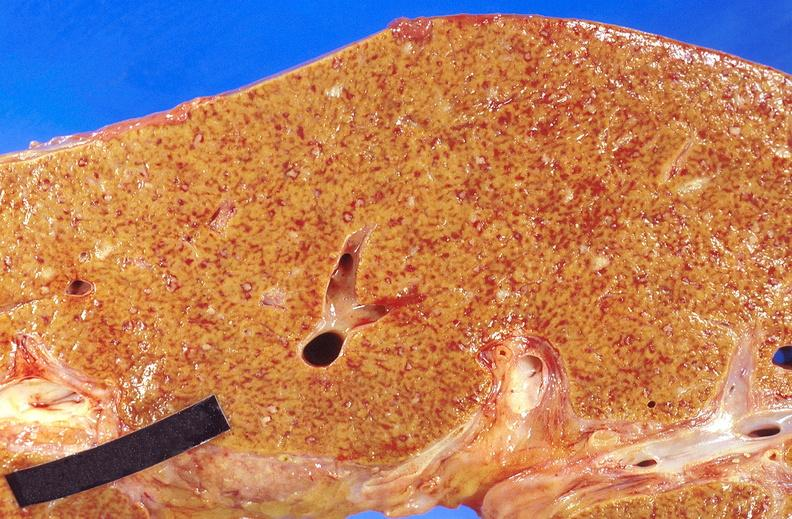does iron show liver, miliary tuberculosis?
Answer the question using a single word or phrase. No 